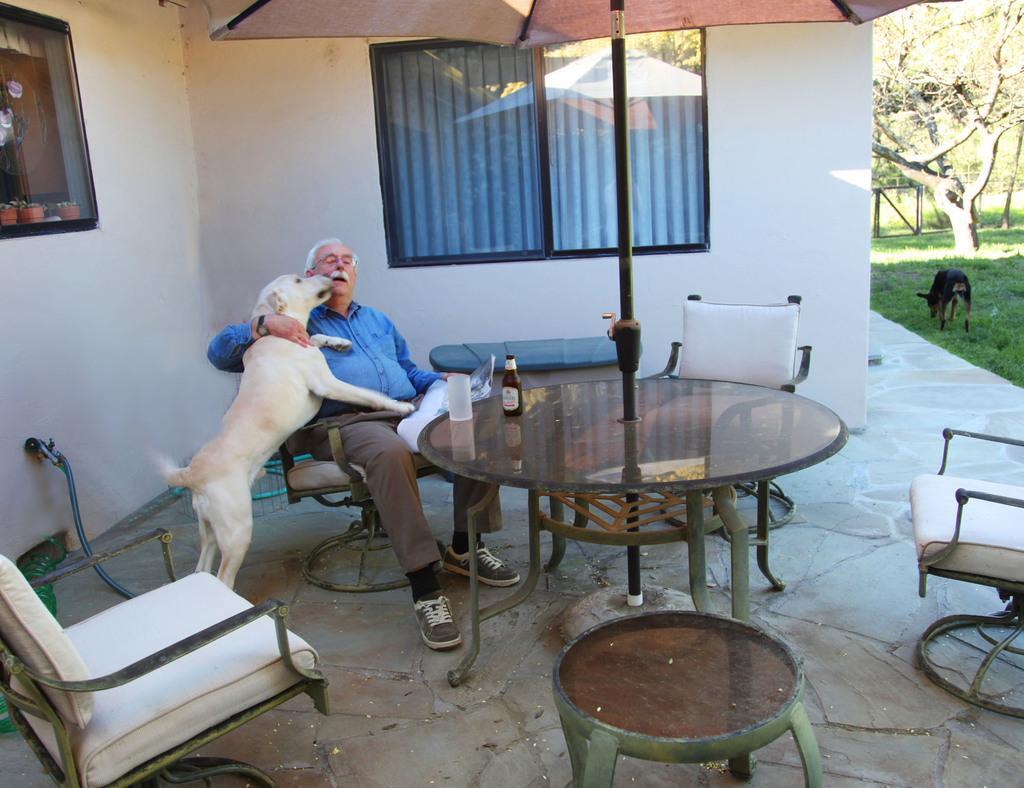How would you summarize this image in a sentence or two? It is a outside view. A man is sat on the chair. We can see white color chairs and glass table. On top of, there is a bottle on it and glass. There is a dog beside him. Background we can see glass window and blue color curtain. On top of the image, we can see umbrella. Right side, there is an another black dog, grass, tree. left side, we can see glass window. 